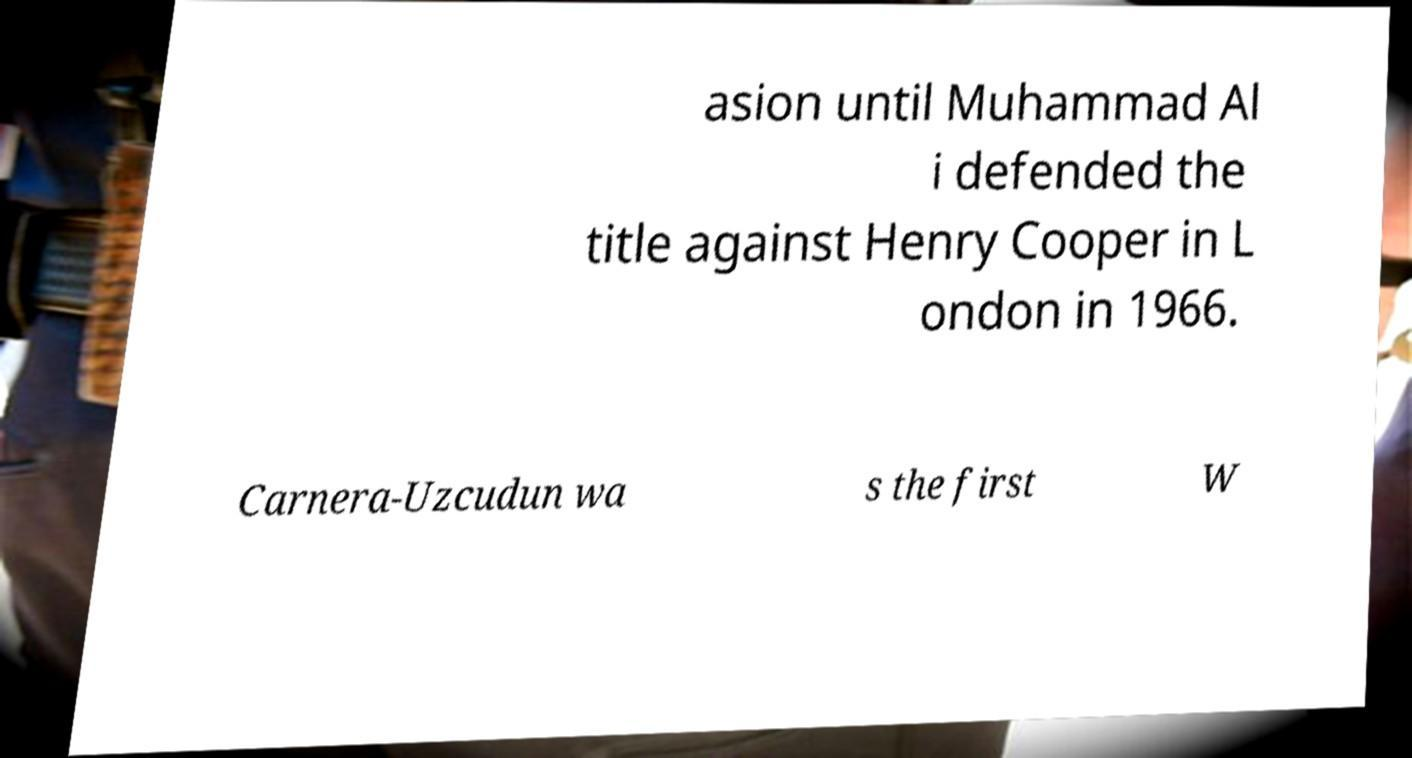What messages or text are displayed in this image? I need them in a readable, typed format. asion until Muhammad Al i defended the title against Henry Cooper in L ondon in 1966. Carnera-Uzcudun wa s the first W 